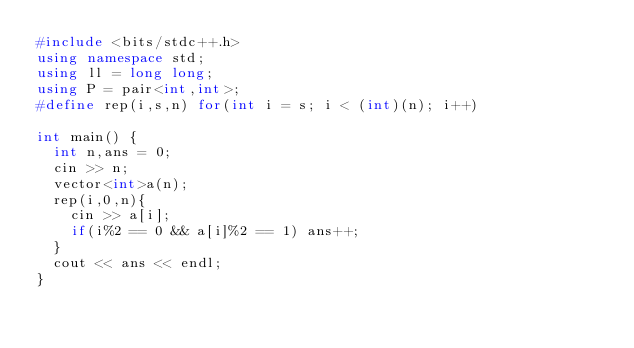Convert code to text. <code><loc_0><loc_0><loc_500><loc_500><_C++_>#include <bits/stdc++.h>
using namespace std;
using ll = long long;
using P = pair<int,int>;
#define rep(i,s,n) for(int i = s; i < (int)(n); i++)

int main() {
  int n,ans = 0;
  cin >> n;
  vector<int>a(n);
  rep(i,0,n){
    cin >> a[i];
    if(i%2 == 0 && a[i]%2 == 1) ans++;
  }
  cout << ans << endl;
}</code> 